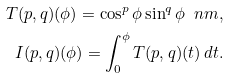<formula> <loc_0><loc_0><loc_500><loc_500>T ( p , q ) ( \phi ) = \cos ^ { p } \phi \sin ^ { q } \phi \ n m , \\ I ( p , q ) ( \phi ) = \int _ { 0 } ^ { \phi } T ( p , q ) ( t ) \, d t .</formula> 